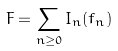<formula> <loc_0><loc_0><loc_500><loc_500>F = \sum _ { n \geq 0 } I _ { n } ( f _ { n } )</formula> 